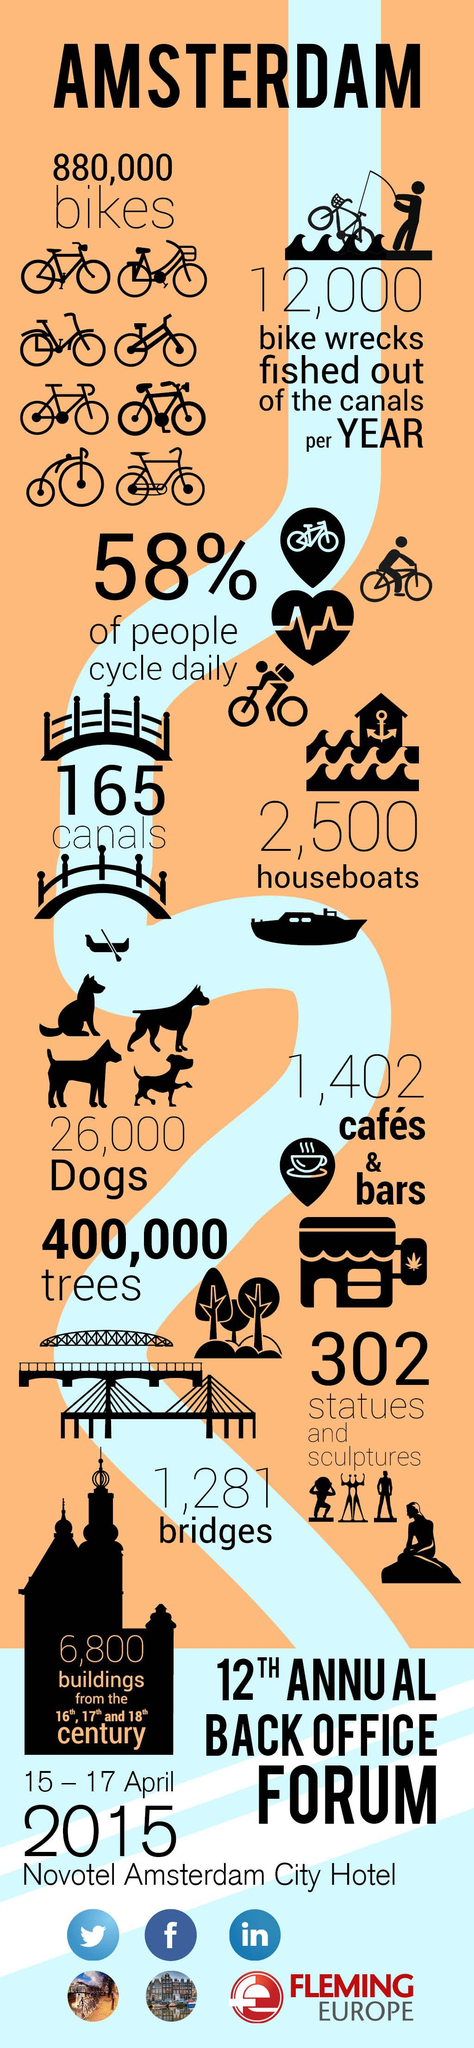Mention a couple of crucial points in this snapshot. In Amsterdam, 42% of people do not cycle, indicating a significant portion of the population chooses not to use bicycles as their primary mode of transportation. 